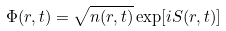<formula> <loc_0><loc_0><loc_500><loc_500>\Phi ( { r } , t ) = \sqrt { n ( { r } , t ) } \exp [ i S ( { r } , t ) ]</formula> 